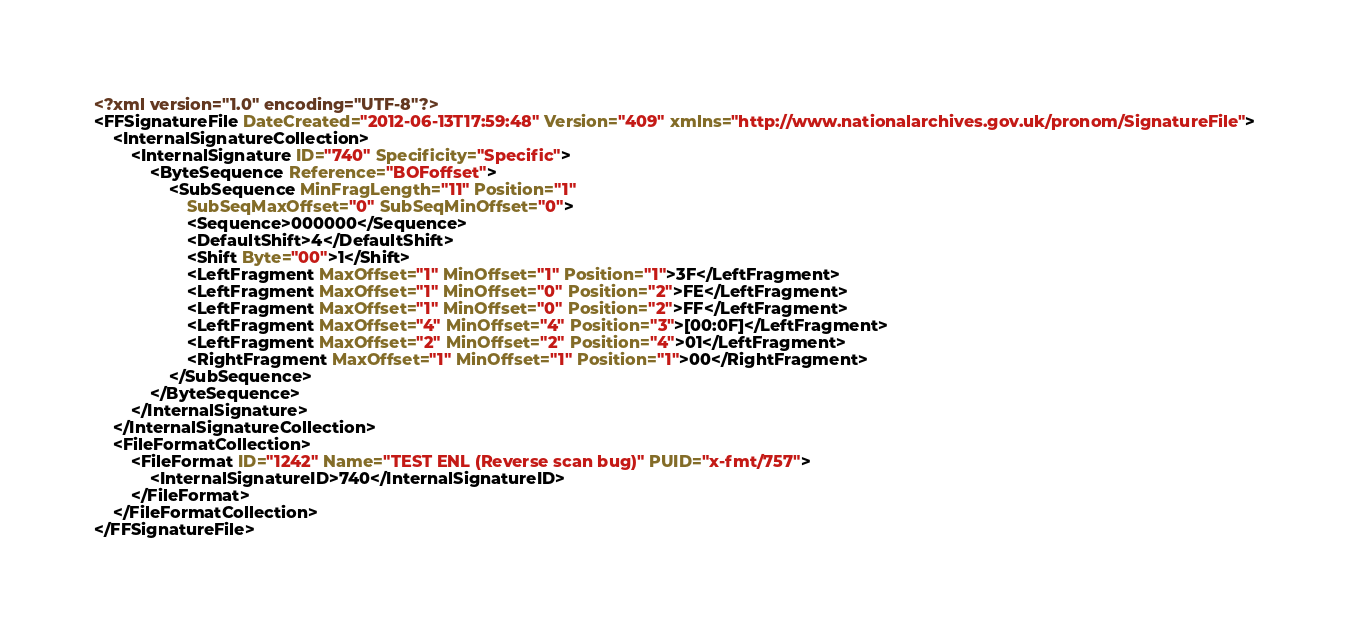<code> <loc_0><loc_0><loc_500><loc_500><_XML_><?xml version="1.0" encoding="UTF-8"?>
<FFSignatureFile DateCreated="2012-06-13T17:59:48" Version="409" xmlns="http://www.nationalarchives.gov.uk/pronom/SignatureFile">
    <InternalSignatureCollection>
        <InternalSignature ID="740" Specificity="Specific">
            <ByteSequence Reference="BOFoffset">
                <SubSequence MinFragLength="11" Position="1"
                    SubSeqMaxOffset="0" SubSeqMinOffset="0">
                    <Sequence>000000</Sequence>
                    <DefaultShift>4</DefaultShift>
                    <Shift Byte="00">1</Shift>
                    <LeftFragment MaxOffset="1" MinOffset="1" Position="1">3F</LeftFragment>
                    <LeftFragment MaxOffset="1" MinOffset="0" Position="2">FE</LeftFragment>
                    <LeftFragment MaxOffset="1" MinOffset="0" Position="2">FF</LeftFragment>
                    <LeftFragment MaxOffset="4" MinOffset="4" Position="3">[00:0F]</LeftFragment>
                    <LeftFragment MaxOffset="2" MinOffset="2" Position="4">01</LeftFragment>
                    <RightFragment MaxOffset="1" MinOffset="1" Position="1">00</RightFragment>
                </SubSequence>
            </ByteSequence>
        </InternalSignature>
    </InternalSignatureCollection>
    <FileFormatCollection>
        <FileFormat ID="1242" Name="TEST ENL (Reverse scan bug)" PUID="x-fmt/757">
            <InternalSignatureID>740</InternalSignatureID>
        </FileFormat>
    </FileFormatCollection>
</FFSignatureFile>
</code> 